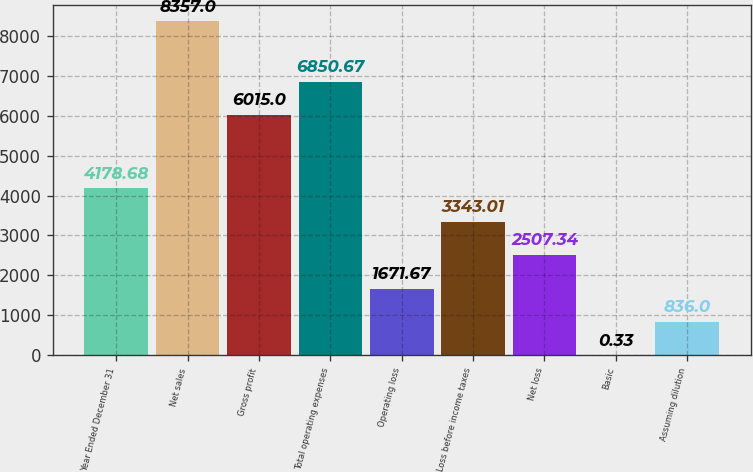<chart> <loc_0><loc_0><loc_500><loc_500><bar_chart><fcel>Year Ended December 31<fcel>Net sales<fcel>Gross profit<fcel>Total operating expenses<fcel>Operating loss<fcel>Loss before income taxes<fcel>Net loss<fcel>Basic<fcel>Assuming dilution<nl><fcel>4178.68<fcel>8357<fcel>6015<fcel>6850.67<fcel>1671.67<fcel>3343.01<fcel>2507.34<fcel>0.33<fcel>836<nl></chart> 